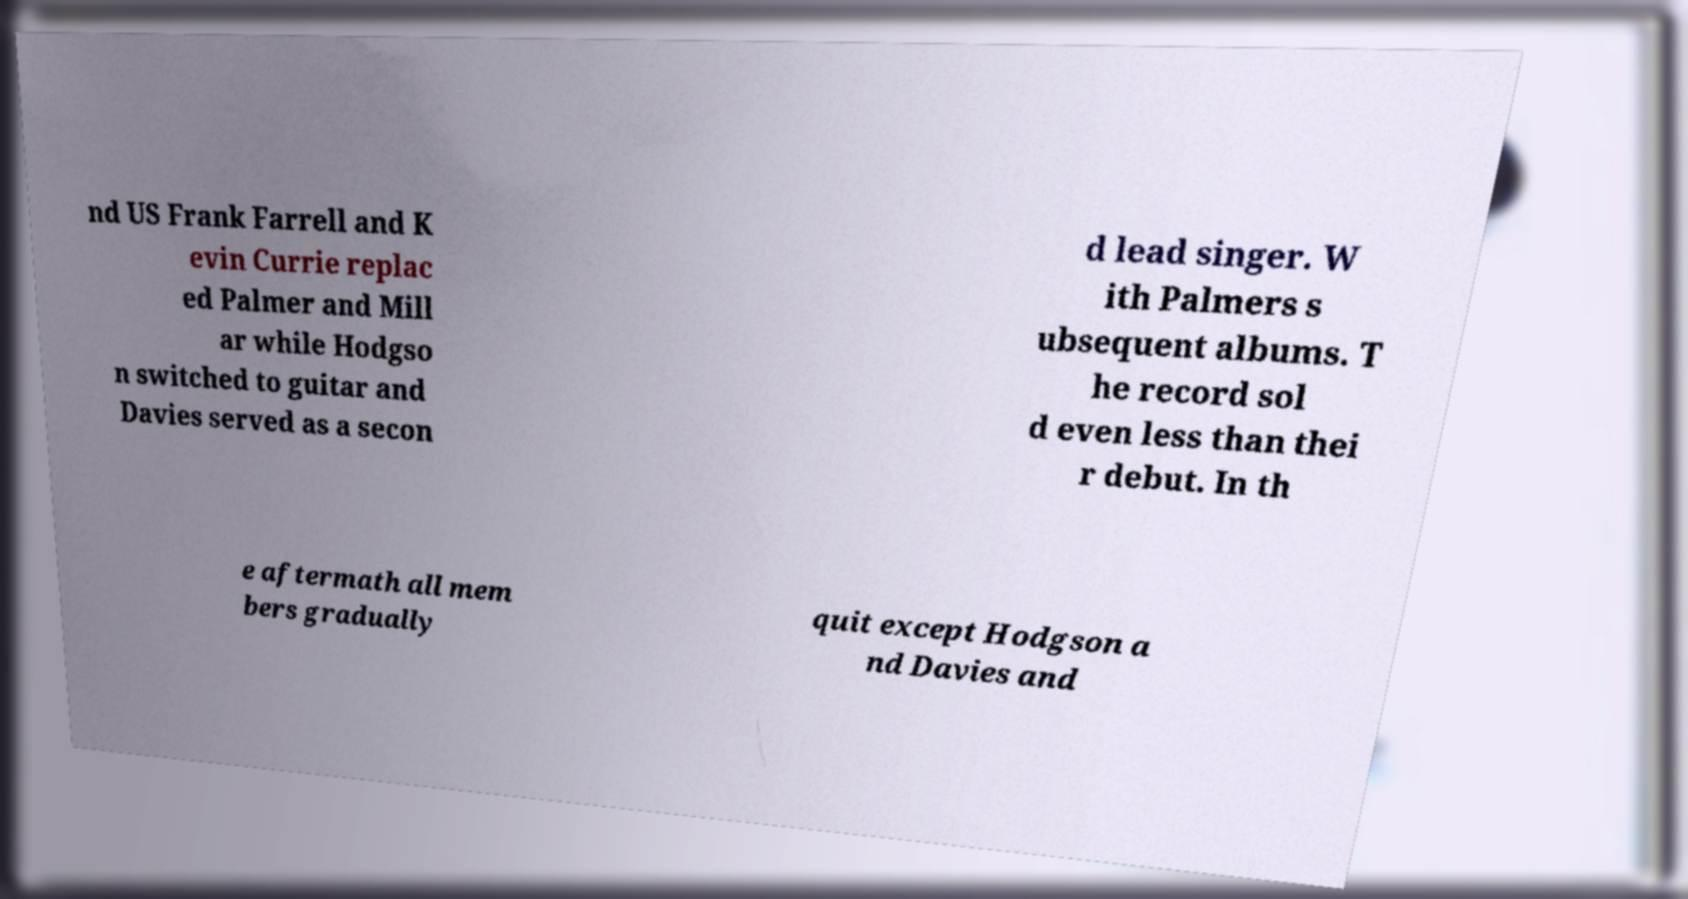What messages or text are displayed in this image? I need them in a readable, typed format. nd US Frank Farrell and K evin Currie replac ed Palmer and Mill ar while Hodgso n switched to guitar and Davies served as a secon d lead singer. W ith Palmers s ubsequent albums. T he record sol d even less than thei r debut. In th e aftermath all mem bers gradually quit except Hodgson a nd Davies and 